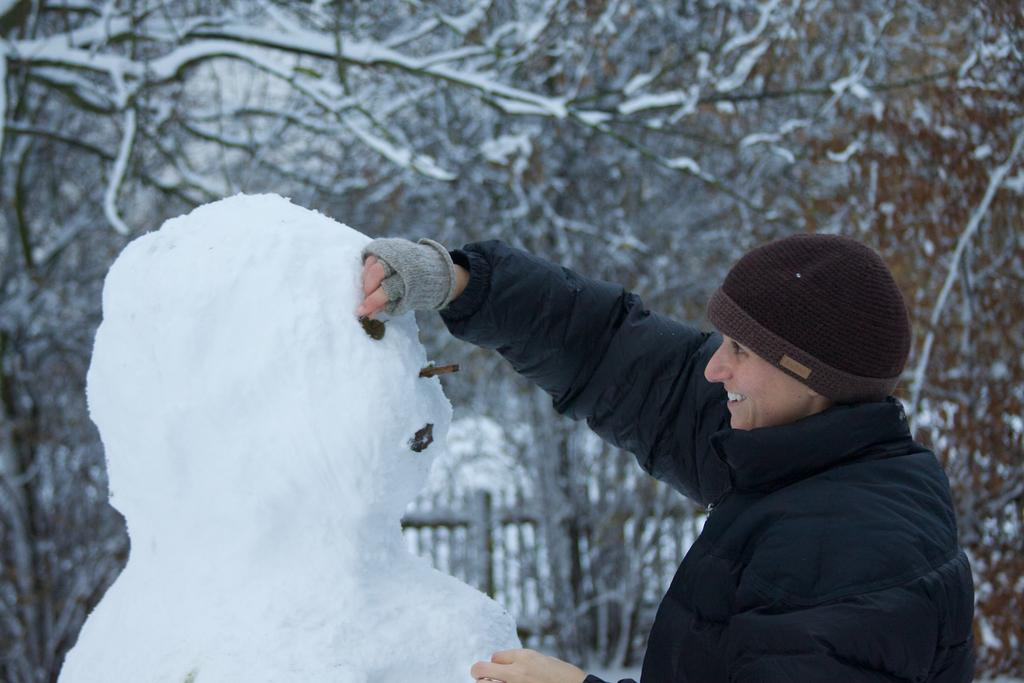What is the person in the image doing? The person is standing in the image and smiling. What type of clothing is the person wearing? The person is wearing a jacket. What can be seen in the background of the image? There are trees and ice visible in the image. What is the weather like in the image? The presence of snow in the image suggests that it is a cold or snowy environment. What type of structure is present in the image? There is fencing in the image. What type of meal is being served in the image? There is no meal present in the image; it features a person standing and smiling in a snowy environment with trees, ice, and fencing. What type of arch can be seen in the image? There is no arch present in the image. 